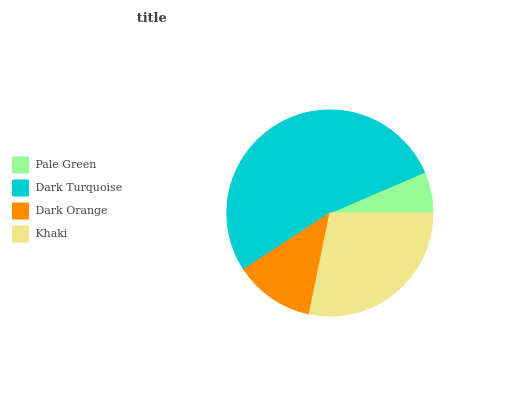Is Pale Green the minimum?
Answer yes or no. Yes. Is Dark Turquoise the maximum?
Answer yes or no. Yes. Is Dark Orange the minimum?
Answer yes or no. No. Is Dark Orange the maximum?
Answer yes or no. No. Is Dark Turquoise greater than Dark Orange?
Answer yes or no. Yes. Is Dark Orange less than Dark Turquoise?
Answer yes or no. Yes. Is Dark Orange greater than Dark Turquoise?
Answer yes or no. No. Is Dark Turquoise less than Dark Orange?
Answer yes or no. No. Is Khaki the high median?
Answer yes or no. Yes. Is Dark Orange the low median?
Answer yes or no. Yes. Is Pale Green the high median?
Answer yes or no. No. Is Khaki the low median?
Answer yes or no. No. 